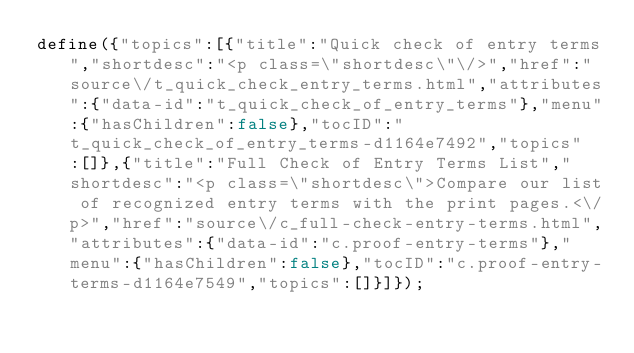Convert code to text. <code><loc_0><loc_0><loc_500><loc_500><_JavaScript_>define({"topics":[{"title":"Quick check of entry terms","shortdesc":"<p class=\"shortdesc\"\/>","href":"source\/t_quick_check_entry_terms.html","attributes":{"data-id":"t_quick_check_of_entry_terms"},"menu":{"hasChildren":false},"tocID":"t_quick_check_of_entry_terms-d1164e7492","topics":[]},{"title":"Full Check of Entry Terms List","shortdesc":"<p class=\"shortdesc\">Compare our list of recognized entry terms with the print pages.<\/p>","href":"source\/c_full-check-entry-terms.html","attributes":{"data-id":"c.proof-entry-terms"},"menu":{"hasChildren":false},"tocID":"c.proof-entry-terms-d1164e7549","topics":[]}]});</code> 